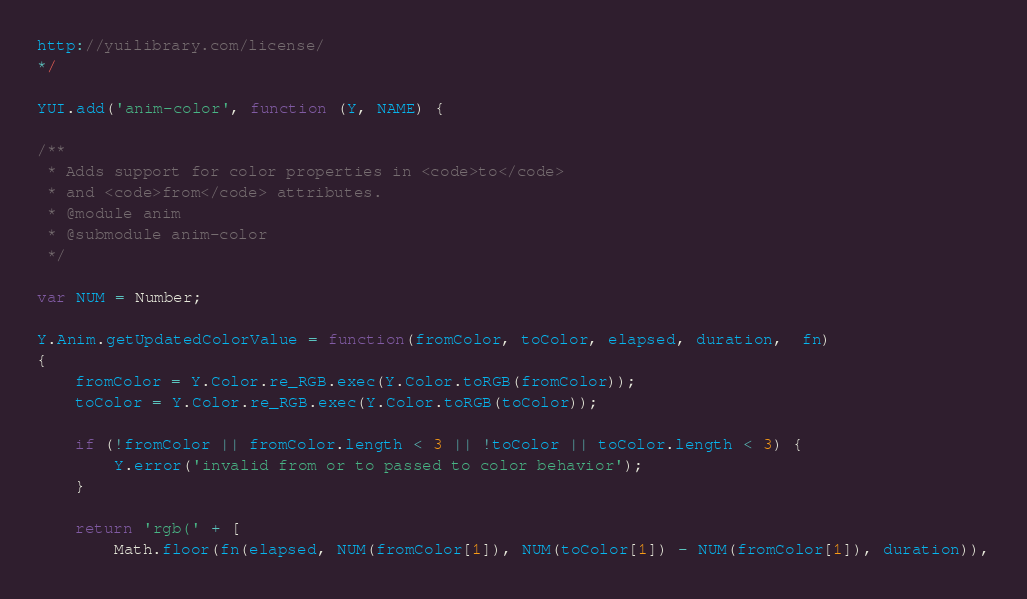Convert code to text. <code><loc_0><loc_0><loc_500><loc_500><_JavaScript_>http://yuilibrary.com/license/
*/

YUI.add('anim-color', function (Y, NAME) {

/**
 * Adds support for color properties in <code>to</code>
 * and <code>from</code> attributes.
 * @module anim
 * @submodule anim-color
 */

var NUM = Number;

Y.Anim.getUpdatedColorValue = function(fromColor, toColor, elapsed, duration,  fn)
{
    fromColor = Y.Color.re_RGB.exec(Y.Color.toRGB(fromColor));
    toColor = Y.Color.re_RGB.exec(Y.Color.toRGB(toColor));

    if (!fromColor || fromColor.length < 3 || !toColor || toColor.length < 3) {
        Y.error('invalid from or to passed to color behavior');
    }

    return 'rgb(' + [
        Math.floor(fn(elapsed, NUM(fromColor[1]), NUM(toColor[1]) - NUM(fromColor[1]), duration)),</code> 